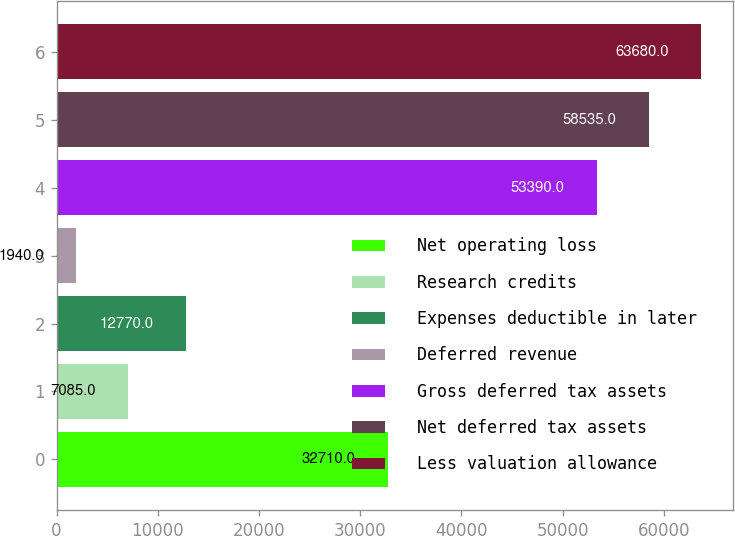<chart> <loc_0><loc_0><loc_500><loc_500><bar_chart><fcel>Net operating loss<fcel>Research credits<fcel>Expenses deductible in later<fcel>Deferred revenue<fcel>Gross deferred tax assets<fcel>Net deferred tax assets<fcel>Less valuation allowance<nl><fcel>32710<fcel>7085<fcel>12770<fcel>1940<fcel>53390<fcel>58535<fcel>63680<nl></chart> 